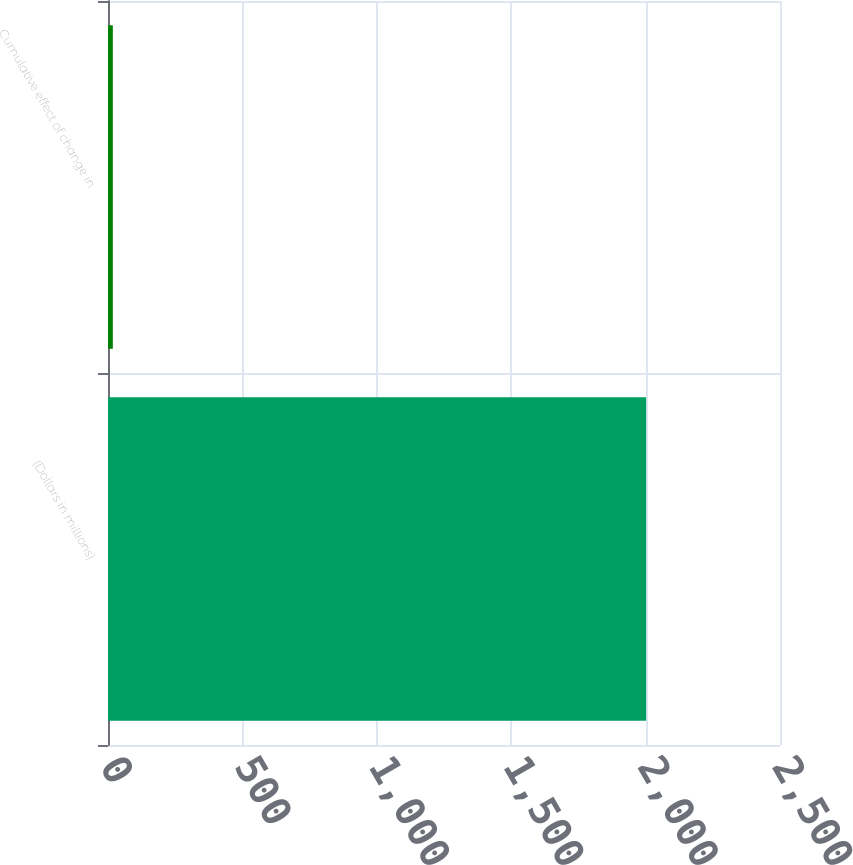Convert chart to OTSL. <chart><loc_0><loc_0><loc_500><loc_500><bar_chart><fcel>(Dollars in millions)<fcel>Cumulative effect of change in<nl><fcel>2002<fcel>18<nl></chart> 